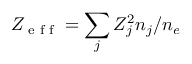Convert formula to latex. <formula><loc_0><loc_0><loc_500><loc_500>Z _ { e f f } = \sum _ { j } Z _ { j } ^ { 2 } n _ { j } / n _ { e }</formula> 